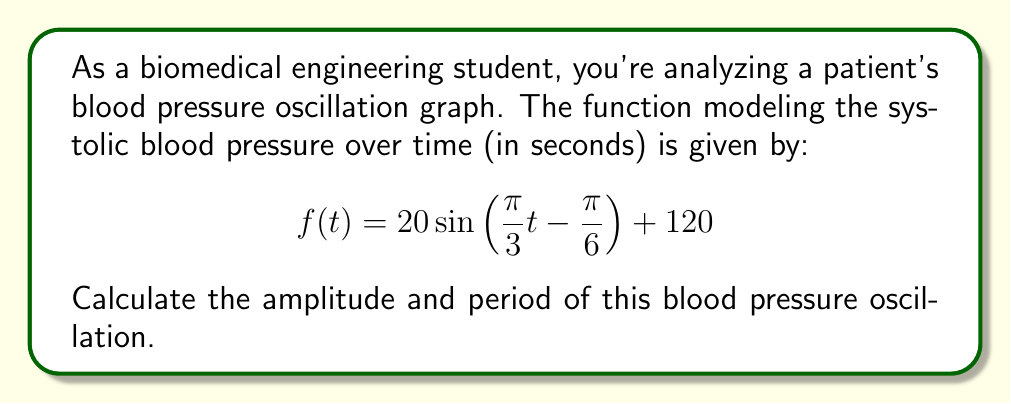Give your solution to this math problem. Let's approach this step-by-step:

1) The general form of a sine function is:
   $$ f(t) = A \sin(Bt - C) + D $$
   where $A$ is the amplitude, $B$ affects the period, $C$ is the phase shift, and $D$ is the vertical shift.

2) Comparing our function to the general form:
   $$ f(t) = 20 \sin\left(\frac{\pi}{3}t - \frac{\pi}{6}\right) + 120 $$
   
   We can identify:
   $A = 20$
   $B = \frac{\pi}{3}$
   $C = \frac{\pi}{6}$
   $D = 120$

3) The amplitude is directly given by $A$, so the amplitude is 20 mmHg.

4) To find the period, we use the formula:
   $$ \text{Period} = \frac{2\pi}{|B|} $$

5) Substituting $B = \frac{\pi}{3}$:
   $$ \text{Period} = \frac{2\pi}{|\frac{\pi}{3}|} = \frac{2\pi}{\frac{\pi}{3}} = 2 \cdot 3 = 6 $$

Therefore, the period is 6 seconds.
Answer: Amplitude: 20 mmHg
Period: 6 seconds 